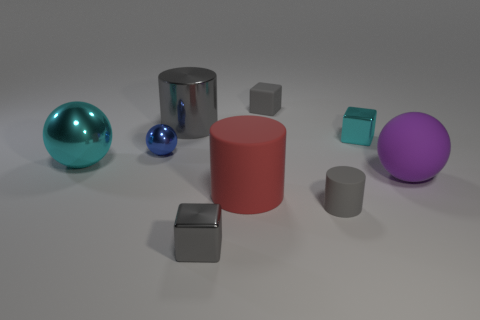Add 1 large cylinders. How many objects exist? 10 Subtract all spheres. How many objects are left? 6 Add 7 blue things. How many blue things are left? 8 Add 5 gray metallic cylinders. How many gray metallic cylinders exist? 6 Subtract 0 red blocks. How many objects are left? 9 Subtract all big brown rubber balls. Subtract all rubber balls. How many objects are left? 8 